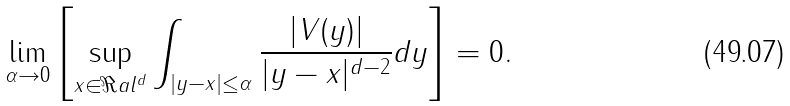<formula> <loc_0><loc_0><loc_500><loc_500>\lim _ { \alpha \rightarrow 0 } \left [ \sup _ { x \in \Re a l ^ { d } } \int _ { | y - x | \leq \alpha } \frac { | V ( y ) | } { | y - x | ^ { d - 2 } } d y \right ] = 0 .</formula> 